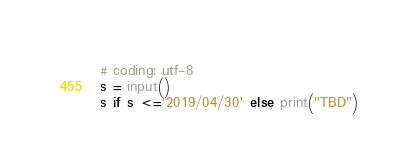<code> <loc_0><loc_0><loc_500><loc_500><_Python_># coding: utf-8
s = input()
s if s <='2019/04/30' else print("TBD")</code> 